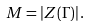<formula> <loc_0><loc_0><loc_500><loc_500>M = | Z ( \Gamma ) | \, .</formula> 